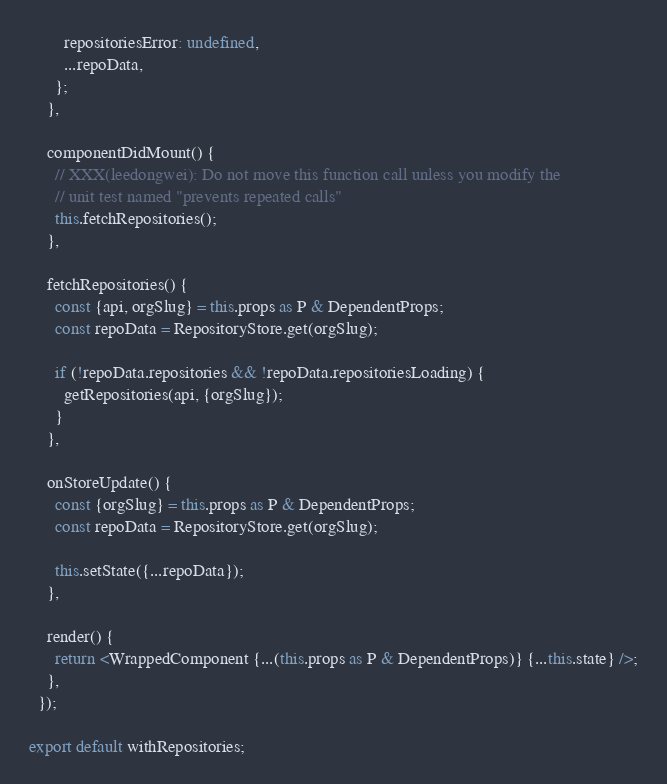Convert code to text. <code><loc_0><loc_0><loc_500><loc_500><_TypeScript_>        repositoriesError: undefined,
        ...repoData,
      };
    },

    componentDidMount() {
      // XXX(leedongwei): Do not move this function call unless you modify the
      // unit test named "prevents repeated calls"
      this.fetchRepositories();
    },

    fetchRepositories() {
      const {api, orgSlug} = this.props as P & DependentProps;
      const repoData = RepositoryStore.get(orgSlug);

      if (!repoData.repositories && !repoData.repositoriesLoading) {
        getRepositories(api, {orgSlug});
      }
    },

    onStoreUpdate() {
      const {orgSlug} = this.props as P & DependentProps;
      const repoData = RepositoryStore.get(orgSlug);

      this.setState({...repoData});
    },

    render() {
      return <WrappedComponent {...(this.props as P & DependentProps)} {...this.state} />;
    },
  });

export default withRepositories;
</code> 